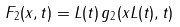<formula> <loc_0><loc_0><loc_500><loc_500>F _ { 2 } ( x , t ) = L ( t ) \, g _ { 2 } ( x L ( t ) , t )</formula> 